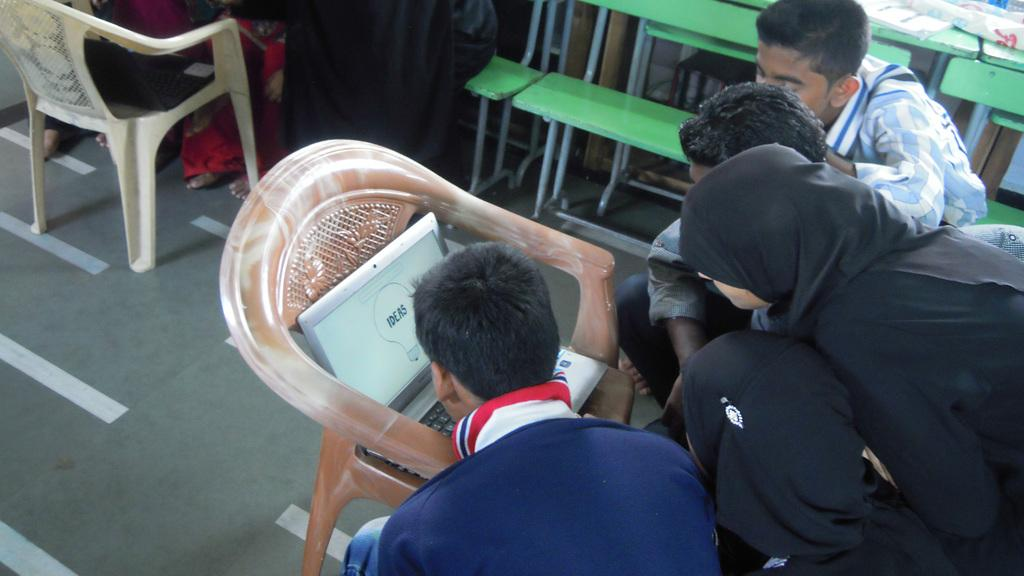What are the people in the image doing? The people in the image are seated. Is there anyone standing in the image? Yes, there is a person standing in the image. What electronic device can be seen in the image? A laptop is present on a chair in the image. What type of furniture is visible in the image? There are benches visible in the image. How many tickets are visible in the image? There are no tickets present in the image. What type of book is being read by the person standing in the image? There is no book visible in the image, as the person standing is not holding or reading a book. 